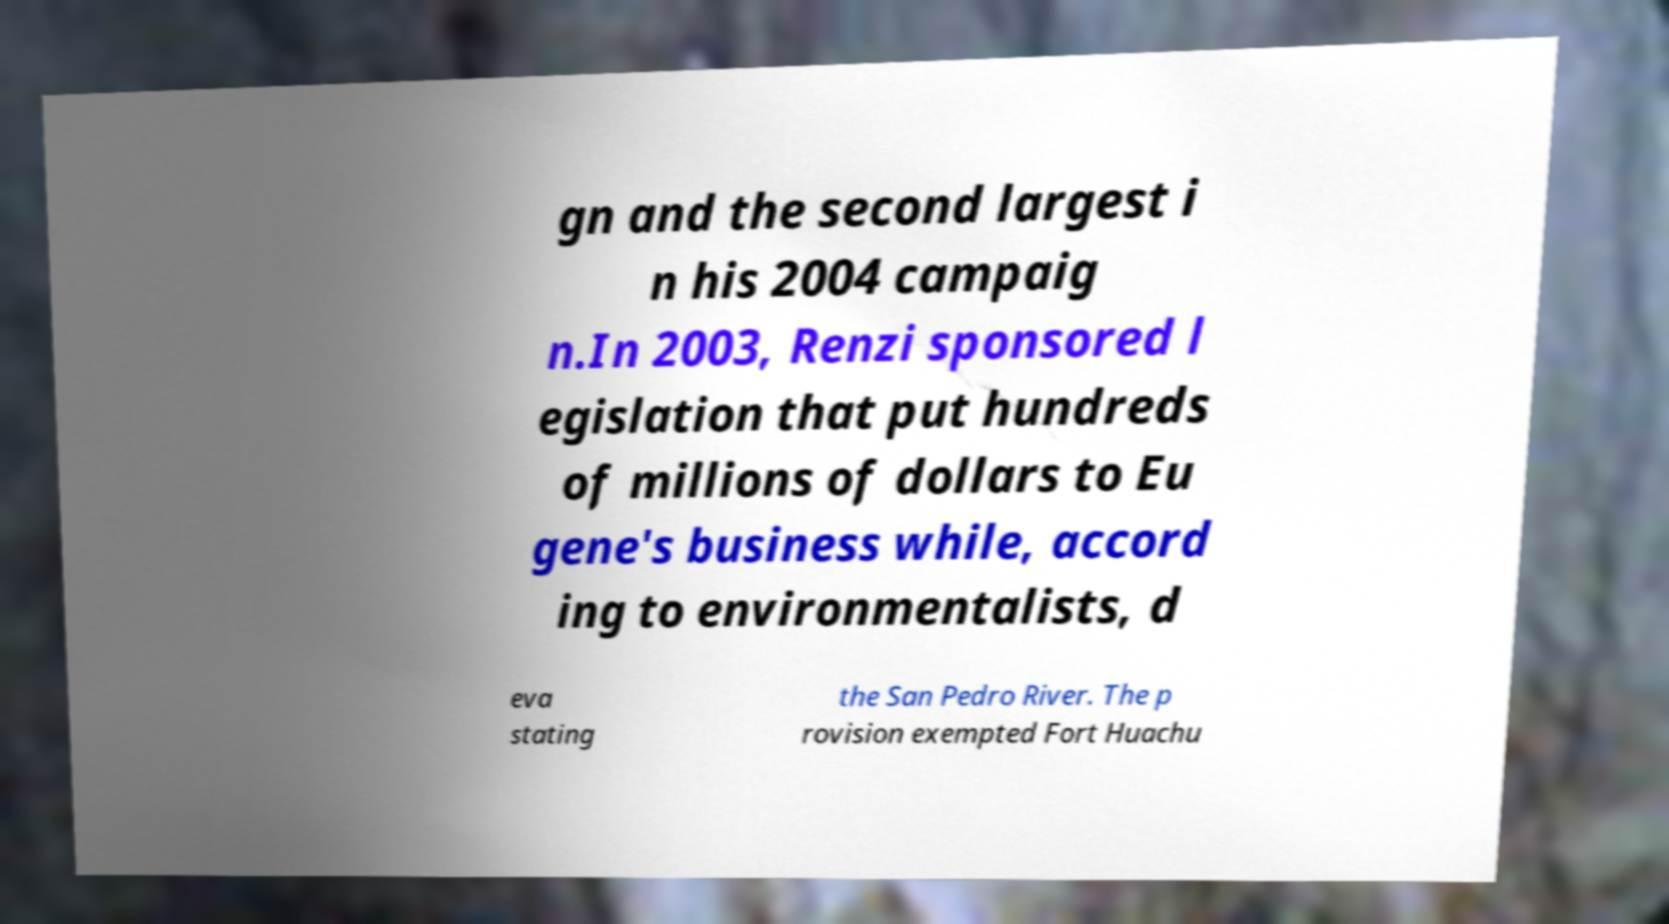For documentation purposes, I need the text within this image transcribed. Could you provide that? gn and the second largest i n his 2004 campaig n.In 2003, Renzi sponsored l egislation that put hundreds of millions of dollars to Eu gene's business while, accord ing to environmentalists, d eva stating the San Pedro River. The p rovision exempted Fort Huachu 